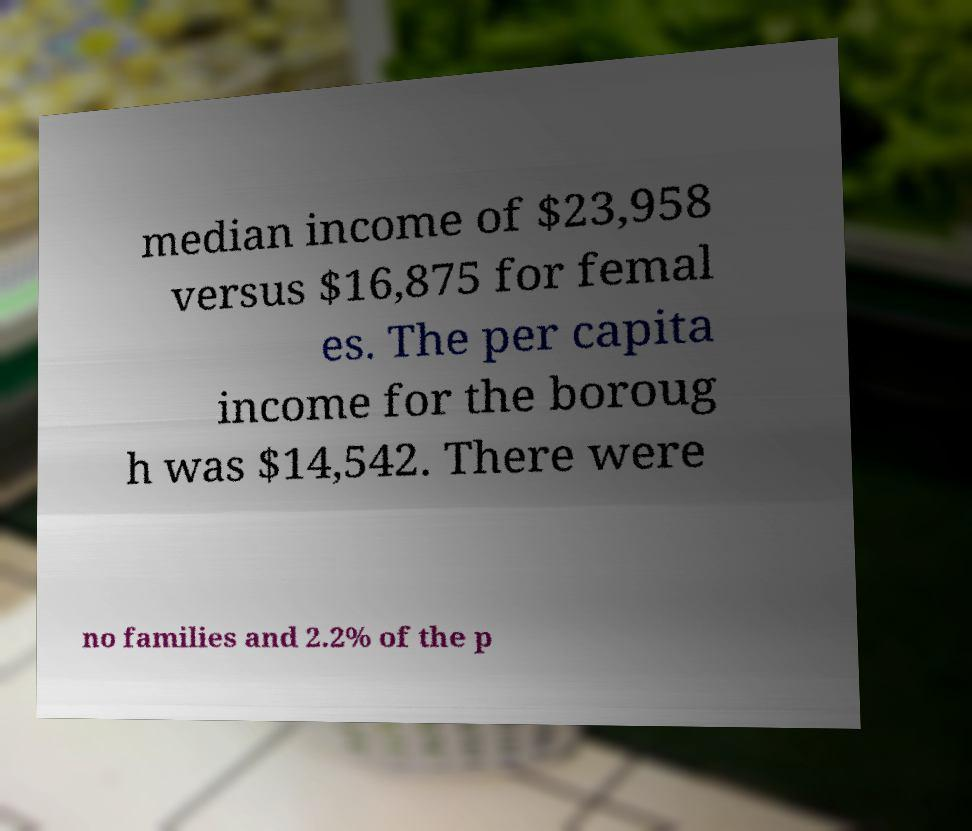Could you assist in decoding the text presented in this image and type it out clearly? median income of $23,958 versus $16,875 for femal es. The per capita income for the boroug h was $14,542. There were no families and 2.2% of the p 